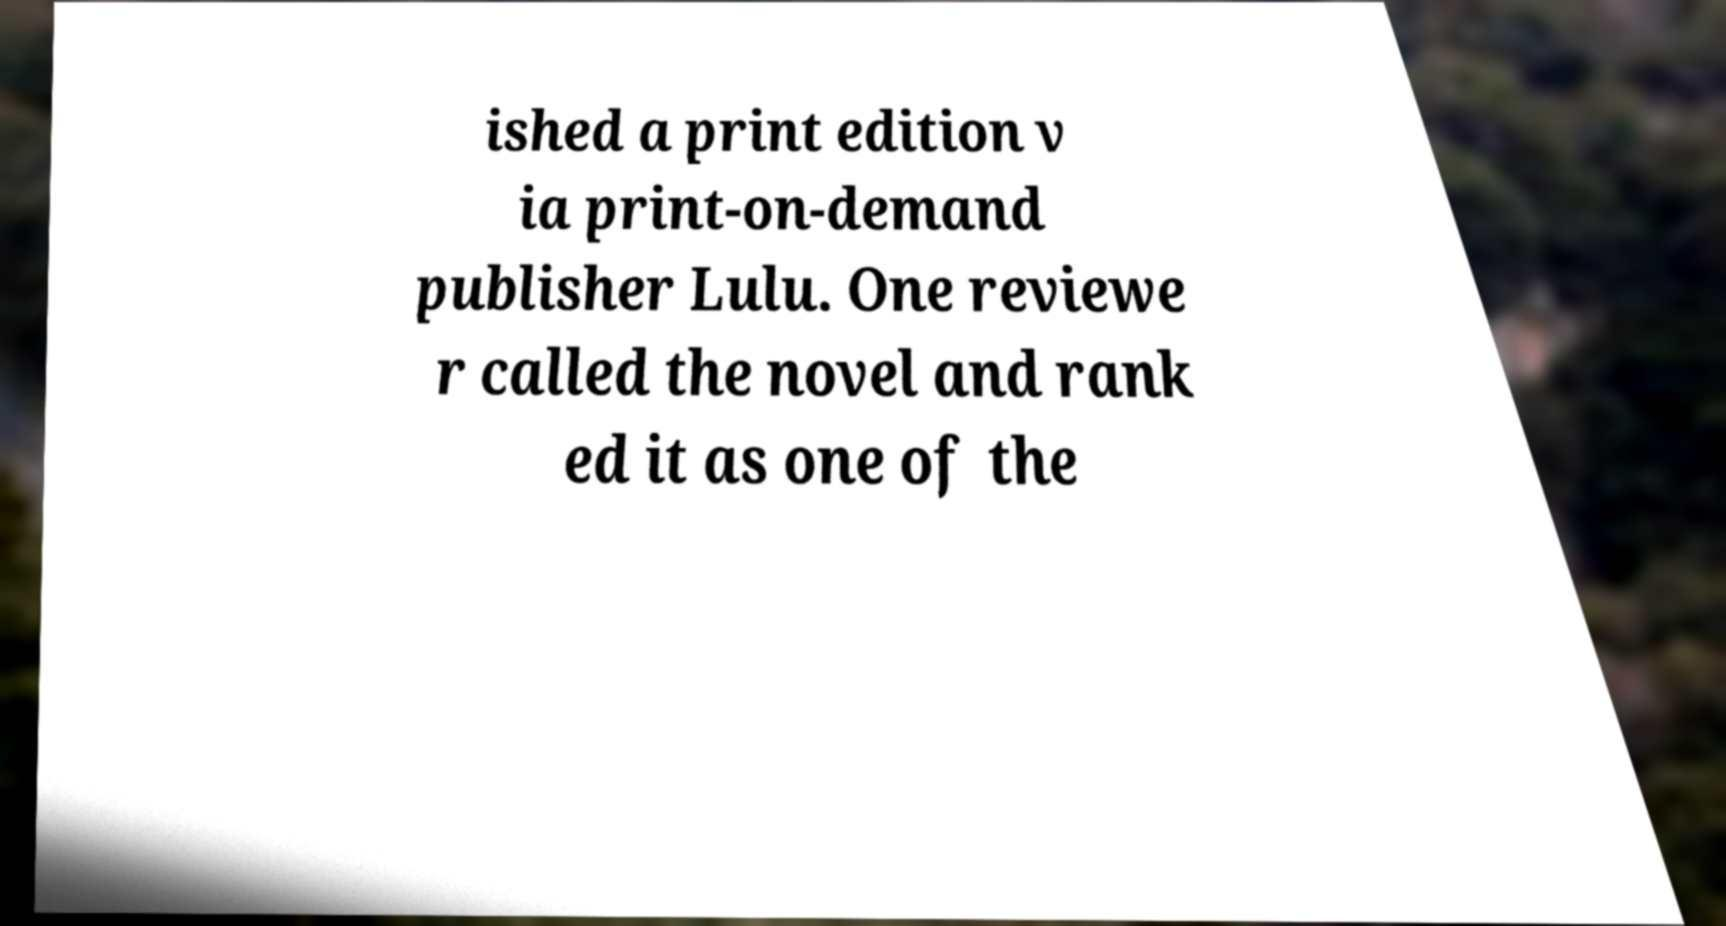Can you accurately transcribe the text from the provided image for me? ished a print edition v ia print-on-demand publisher Lulu. One reviewe r called the novel and rank ed it as one of the 